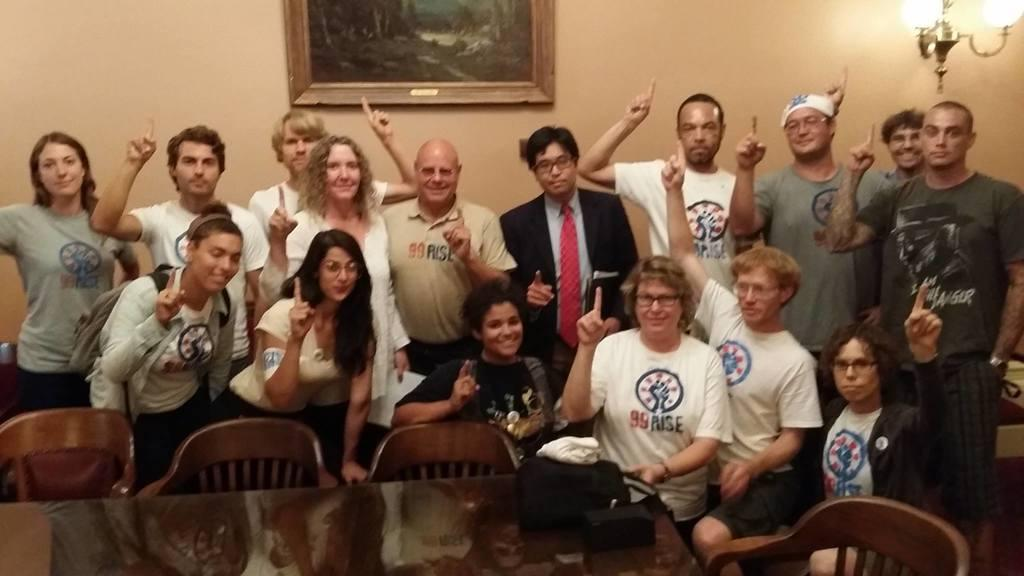What type of furniture is located at the bottom side of the image? There is a table and chairs at the bottom side of the image. What can be seen in the center of the image? There are people in the center of the image. What object is present in the image that has a border or edge? There is a frame in the image. What type of lighting is visible at the top side of the image? There are lamps at the top side of the image. What type of detail can be seen on the judge's robe in the image? There is no judge or robe present in the image. How does the sleet affect the people in the image? There is no mention of sleet in the image; it is not present. 